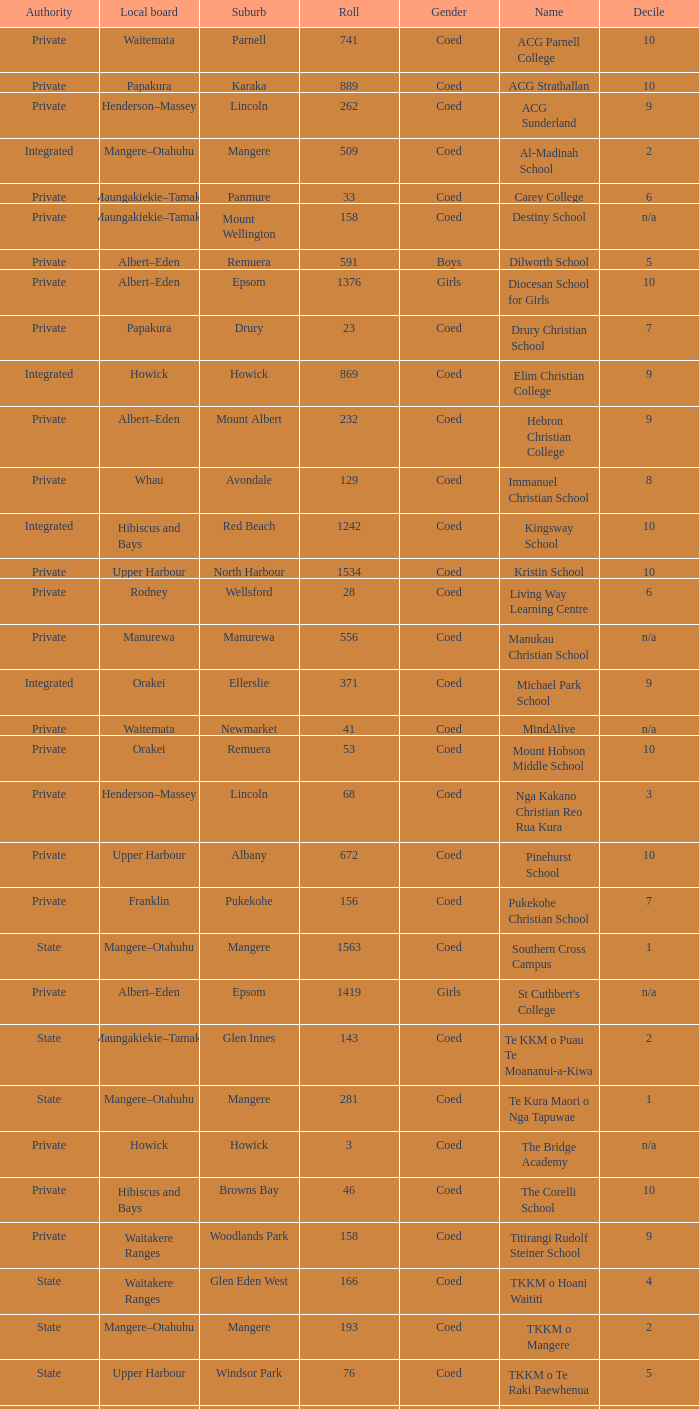What is the name when the local board is albert–eden, and a Decile of 9? Hebron Christian College. 